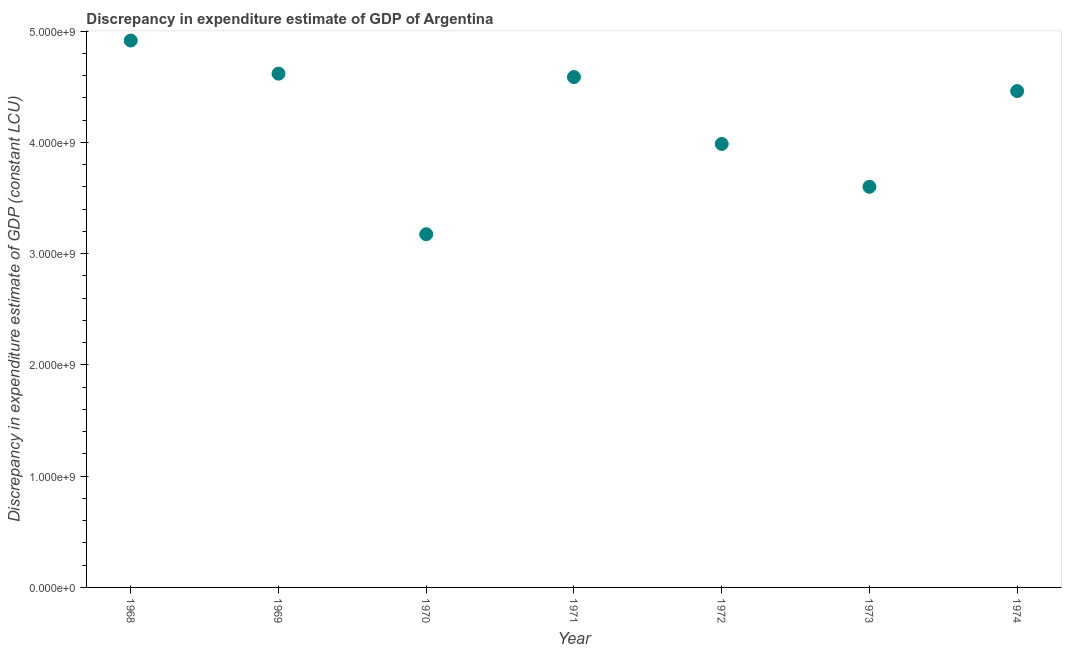What is the discrepancy in expenditure estimate of gdp in 1972?
Make the answer very short. 3.99e+09. Across all years, what is the maximum discrepancy in expenditure estimate of gdp?
Give a very brief answer. 4.92e+09. Across all years, what is the minimum discrepancy in expenditure estimate of gdp?
Your answer should be very brief. 3.17e+09. In which year was the discrepancy in expenditure estimate of gdp maximum?
Give a very brief answer. 1968. In which year was the discrepancy in expenditure estimate of gdp minimum?
Your answer should be very brief. 1970. What is the sum of the discrepancy in expenditure estimate of gdp?
Offer a terse response. 2.93e+1. What is the difference between the discrepancy in expenditure estimate of gdp in 1970 and 1973?
Keep it short and to the point. -4.27e+08. What is the average discrepancy in expenditure estimate of gdp per year?
Provide a short and direct response. 4.19e+09. What is the median discrepancy in expenditure estimate of gdp?
Offer a very short reply. 4.46e+09. In how many years, is the discrepancy in expenditure estimate of gdp greater than 1200000000 LCU?
Ensure brevity in your answer.  7. What is the ratio of the discrepancy in expenditure estimate of gdp in 1968 to that in 1974?
Provide a succinct answer. 1.1. What is the difference between the highest and the second highest discrepancy in expenditure estimate of gdp?
Make the answer very short. 2.98e+08. Is the sum of the discrepancy in expenditure estimate of gdp in 1970 and 1973 greater than the maximum discrepancy in expenditure estimate of gdp across all years?
Your answer should be very brief. Yes. What is the difference between the highest and the lowest discrepancy in expenditure estimate of gdp?
Provide a short and direct response. 1.74e+09. In how many years, is the discrepancy in expenditure estimate of gdp greater than the average discrepancy in expenditure estimate of gdp taken over all years?
Your answer should be compact. 4. How many dotlines are there?
Make the answer very short. 1. What is the difference between two consecutive major ticks on the Y-axis?
Make the answer very short. 1.00e+09. What is the title of the graph?
Give a very brief answer. Discrepancy in expenditure estimate of GDP of Argentina. What is the label or title of the Y-axis?
Offer a terse response. Discrepancy in expenditure estimate of GDP (constant LCU). What is the Discrepancy in expenditure estimate of GDP (constant LCU) in 1968?
Give a very brief answer. 4.92e+09. What is the Discrepancy in expenditure estimate of GDP (constant LCU) in 1969?
Offer a very short reply. 4.62e+09. What is the Discrepancy in expenditure estimate of GDP (constant LCU) in 1970?
Keep it short and to the point. 3.17e+09. What is the Discrepancy in expenditure estimate of GDP (constant LCU) in 1971?
Your response must be concise. 4.59e+09. What is the Discrepancy in expenditure estimate of GDP (constant LCU) in 1972?
Your answer should be very brief. 3.99e+09. What is the Discrepancy in expenditure estimate of GDP (constant LCU) in 1973?
Make the answer very short. 3.60e+09. What is the Discrepancy in expenditure estimate of GDP (constant LCU) in 1974?
Make the answer very short. 4.46e+09. What is the difference between the Discrepancy in expenditure estimate of GDP (constant LCU) in 1968 and 1969?
Your response must be concise. 2.98e+08. What is the difference between the Discrepancy in expenditure estimate of GDP (constant LCU) in 1968 and 1970?
Make the answer very short. 1.74e+09. What is the difference between the Discrepancy in expenditure estimate of GDP (constant LCU) in 1968 and 1971?
Provide a succinct answer. 3.28e+08. What is the difference between the Discrepancy in expenditure estimate of GDP (constant LCU) in 1968 and 1972?
Your response must be concise. 9.30e+08. What is the difference between the Discrepancy in expenditure estimate of GDP (constant LCU) in 1968 and 1973?
Give a very brief answer. 1.32e+09. What is the difference between the Discrepancy in expenditure estimate of GDP (constant LCU) in 1968 and 1974?
Ensure brevity in your answer.  4.54e+08. What is the difference between the Discrepancy in expenditure estimate of GDP (constant LCU) in 1969 and 1970?
Keep it short and to the point. 1.44e+09. What is the difference between the Discrepancy in expenditure estimate of GDP (constant LCU) in 1969 and 1971?
Keep it short and to the point. 3.03e+07. What is the difference between the Discrepancy in expenditure estimate of GDP (constant LCU) in 1969 and 1972?
Your response must be concise. 6.32e+08. What is the difference between the Discrepancy in expenditure estimate of GDP (constant LCU) in 1969 and 1973?
Ensure brevity in your answer.  1.02e+09. What is the difference between the Discrepancy in expenditure estimate of GDP (constant LCU) in 1969 and 1974?
Offer a terse response. 1.56e+08. What is the difference between the Discrepancy in expenditure estimate of GDP (constant LCU) in 1970 and 1971?
Provide a succinct answer. -1.41e+09. What is the difference between the Discrepancy in expenditure estimate of GDP (constant LCU) in 1970 and 1972?
Offer a very short reply. -8.12e+08. What is the difference between the Discrepancy in expenditure estimate of GDP (constant LCU) in 1970 and 1973?
Keep it short and to the point. -4.27e+08. What is the difference between the Discrepancy in expenditure estimate of GDP (constant LCU) in 1970 and 1974?
Keep it short and to the point. -1.29e+09. What is the difference between the Discrepancy in expenditure estimate of GDP (constant LCU) in 1971 and 1972?
Your answer should be very brief. 6.02e+08. What is the difference between the Discrepancy in expenditure estimate of GDP (constant LCU) in 1971 and 1973?
Provide a short and direct response. 9.87e+08. What is the difference between the Discrepancy in expenditure estimate of GDP (constant LCU) in 1971 and 1974?
Offer a very short reply. 1.26e+08. What is the difference between the Discrepancy in expenditure estimate of GDP (constant LCU) in 1972 and 1973?
Make the answer very short. 3.85e+08. What is the difference between the Discrepancy in expenditure estimate of GDP (constant LCU) in 1972 and 1974?
Offer a very short reply. -4.76e+08. What is the difference between the Discrepancy in expenditure estimate of GDP (constant LCU) in 1973 and 1974?
Your answer should be very brief. -8.61e+08. What is the ratio of the Discrepancy in expenditure estimate of GDP (constant LCU) in 1968 to that in 1969?
Provide a short and direct response. 1.06. What is the ratio of the Discrepancy in expenditure estimate of GDP (constant LCU) in 1968 to that in 1970?
Your answer should be compact. 1.55. What is the ratio of the Discrepancy in expenditure estimate of GDP (constant LCU) in 1968 to that in 1971?
Make the answer very short. 1.07. What is the ratio of the Discrepancy in expenditure estimate of GDP (constant LCU) in 1968 to that in 1972?
Your answer should be compact. 1.23. What is the ratio of the Discrepancy in expenditure estimate of GDP (constant LCU) in 1968 to that in 1973?
Make the answer very short. 1.36. What is the ratio of the Discrepancy in expenditure estimate of GDP (constant LCU) in 1968 to that in 1974?
Your response must be concise. 1.1. What is the ratio of the Discrepancy in expenditure estimate of GDP (constant LCU) in 1969 to that in 1970?
Your response must be concise. 1.46. What is the ratio of the Discrepancy in expenditure estimate of GDP (constant LCU) in 1969 to that in 1971?
Provide a succinct answer. 1.01. What is the ratio of the Discrepancy in expenditure estimate of GDP (constant LCU) in 1969 to that in 1972?
Your response must be concise. 1.16. What is the ratio of the Discrepancy in expenditure estimate of GDP (constant LCU) in 1969 to that in 1973?
Provide a succinct answer. 1.28. What is the ratio of the Discrepancy in expenditure estimate of GDP (constant LCU) in 1969 to that in 1974?
Offer a very short reply. 1.03. What is the ratio of the Discrepancy in expenditure estimate of GDP (constant LCU) in 1970 to that in 1971?
Your response must be concise. 0.69. What is the ratio of the Discrepancy in expenditure estimate of GDP (constant LCU) in 1970 to that in 1972?
Give a very brief answer. 0.8. What is the ratio of the Discrepancy in expenditure estimate of GDP (constant LCU) in 1970 to that in 1973?
Offer a very short reply. 0.88. What is the ratio of the Discrepancy in expenditure estimate of GDP (constant LCU) in 1970 to that in 1974?
Your response must be concise. 0.71. What is the ratio of the Discrepancy in expenditure estimate of GDP (constant LCU) in 1971 to that in 1972?
Your answer should be very brief. 1.15. What is the ratio of the Discrepancy in expenditure estimate of GDP (constant LCU) in 1971 to that in 1973?
Keep it short and to the point. 1.27. What is the ratio of the Discrepancy in expenditure estimate of GDP (constant LCU) in 1971 to that in 1974?
Offer a terse response. 1.03. What is the ratio of the Discrepancy in expenditure estimate of GDP (constant LCU) in 1972 to that in 1973?
Provide a succinct answer. 1.11. What is the ratio of the Discrepancy in expenditure estimate of GDP (constant LCU) in 1972 to that in 1974?
Your answer should be compact. 0.89. What is the ratio of the Discrepancy in expenditure estimate of GDP (constant LCU) in 1973 to that in 1974?
Your answer should be very brief. 0.81. 